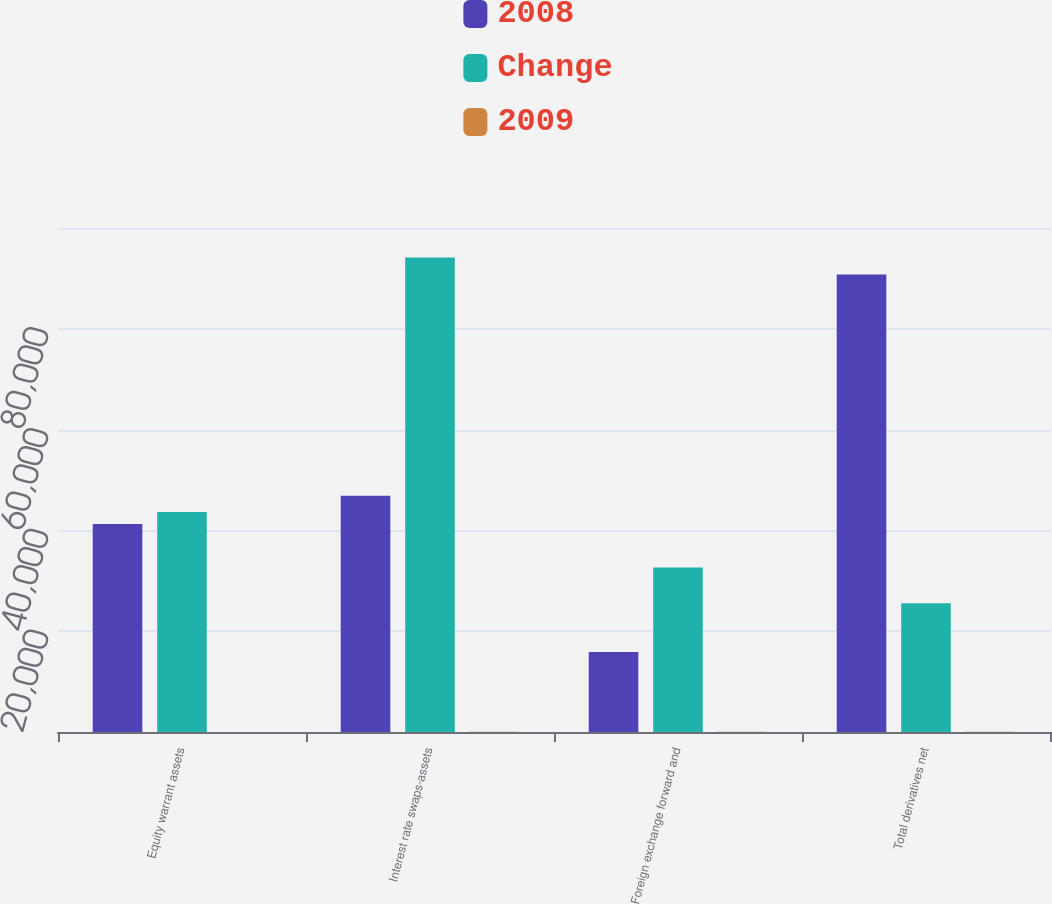<chart> <loc_0><loc_0><loc_500><loc_500><stacked_bar_chart><ecel><fcel>Equity warrant assets<fcel>Interest rate swaps-assets<fcel>Foreign exchange forward and<fcel>Total derivatives net<nl><fcel>2008<fcel>41292<fcel>46895<fcel>15870<fcel>90753<nl><fcel>Change<fcel>43659<fcel>94142<fcel>32632<fcel>25534<nl><fcel>2009<fcel>5.4<fcel>50.2<fcel>51.4<fcel>36.3<nl></chart> 